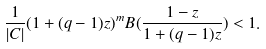Convert formula to latex. <formula><loc_0><loc_0><loc_500><loc_500>\frac { 1 } { | C | } ( 1 + ( q - 1 ) z ) ^ { m } B ( \frac { 1 - z } { 1 + ( q - 1 ) z } ) < 1 .</formula> 